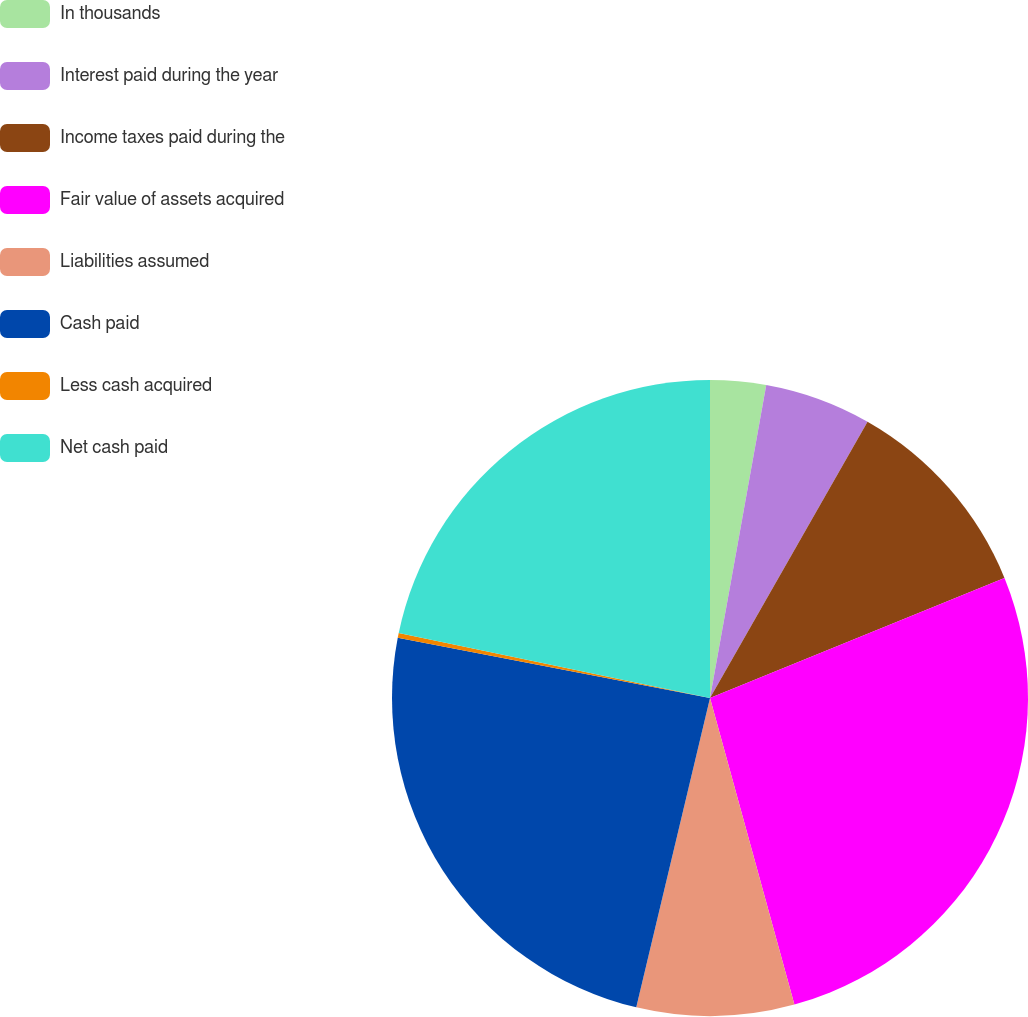Convert chart. <chart><loc_0><loc_0><loc_500><loc_500><pie_chart><fcel>In thousands<fcel>Interest paid during the year<fcel>Income taxes paid during the<fcel>Fair value of assets acquired<fcel>Liabilities assumed<fcel>Cash paid<fcel>Less cash acquired<fcel>Net cash paid<nl><fcel>2.83%<fcel>5.42%<fcel>10.59%<fcel>26.89%<fcel>8.0%<fcel>24.31%<fcel>0.25%<fcel>21.72%<nl></chart> 